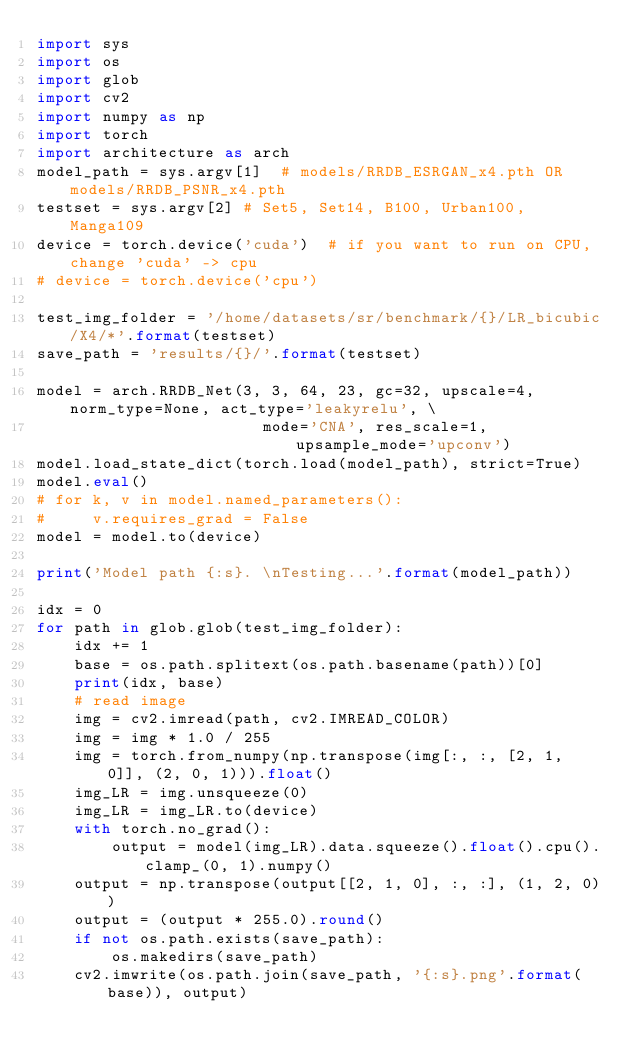<code> <loc_0><loc_0><loc_500><loc_500><_Python_>import sys
import os
import glob
import cv2
import numpy as np
import torch
import architecture as arch
model_path = sys.argv[1]  # models/RRDB_ESRGAN_x4.pth OR models/RRDB_PSNR_x4.pth
testset = sys.argv[2] # Set5, Set14, B100, Urban100, Manga109
device = torch.device('cuda')  # if you want to run on CPU, change 'cuda' -> cpu
# device = torch.device('cpu')

test_img_folder = '/home/datasets/sr/benchmark/{}/LR_bicubic/X4/*'.format(testset)
save_path = 'results/{}/'.format(testset)

model = arch.RRDB_Net(3, 3, 64, 23, gc=32, upscale=4, norm_type=None, act_type='leakyrelu', \
                        mode='CNA', res_scale=1, upsample_mode='upconv')
model.load_state_dict(torch.load(model_path), strict=True)
model.eval()
# for k, v in model.named_parameters():
#     v.requires_grad = False
model = model.to(device)

print('Model path {:s}. \nTesting...'.format(model_path))

idx = 0
for path in glob.glob(test_img_folder):
    idx += 1
    base = os.path.splitext(os.path.basename(path))[0]
    print(idx, base)
    # read image
    img = cv2.imread(path, cv2.IMREAD_COLOR)
    img = img * 1.0 / 255
    img = torch.from_numpy(np.transpose(img[:, :, [2, 1, 0]], (2, 0, 1))).float()
    img_LR = img.unsqueeze(0)
    img_LR = img_LR.to(device)
    with torch.no_grad():
        output = model(img_LR).data.squeeze().float().cpu().clamp_(0, 1).numpy()
    output = np.transpose(output[[2, 1, 0], :, :], (1, 2, 0))
    output = (output * 255.0).round()
    if not os.path.exists(save_path):
        os.makedirs(save_path)
    cv2.imwrite(os.path.join(save_path, '{:s}.png'.format(base)), output)
</code> 